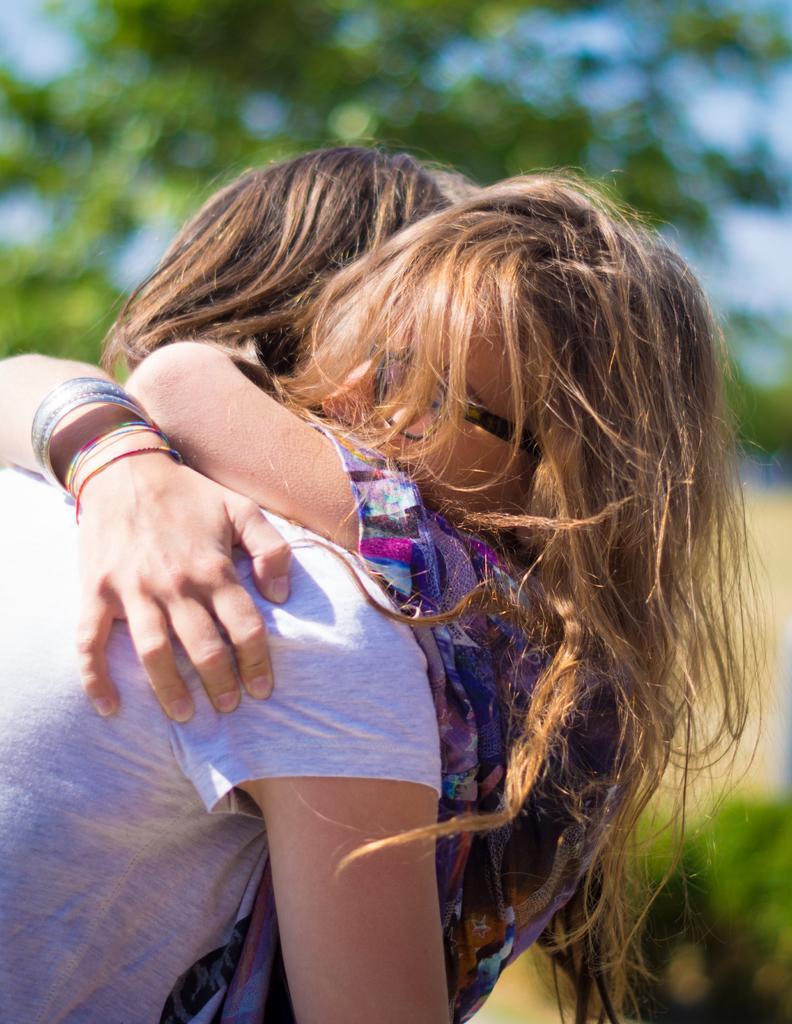In one or two sentences, can you explain what this image depicts? There are two persons hugging each other. One person is wearing bangles and specs. In the background it is green and blurred. 